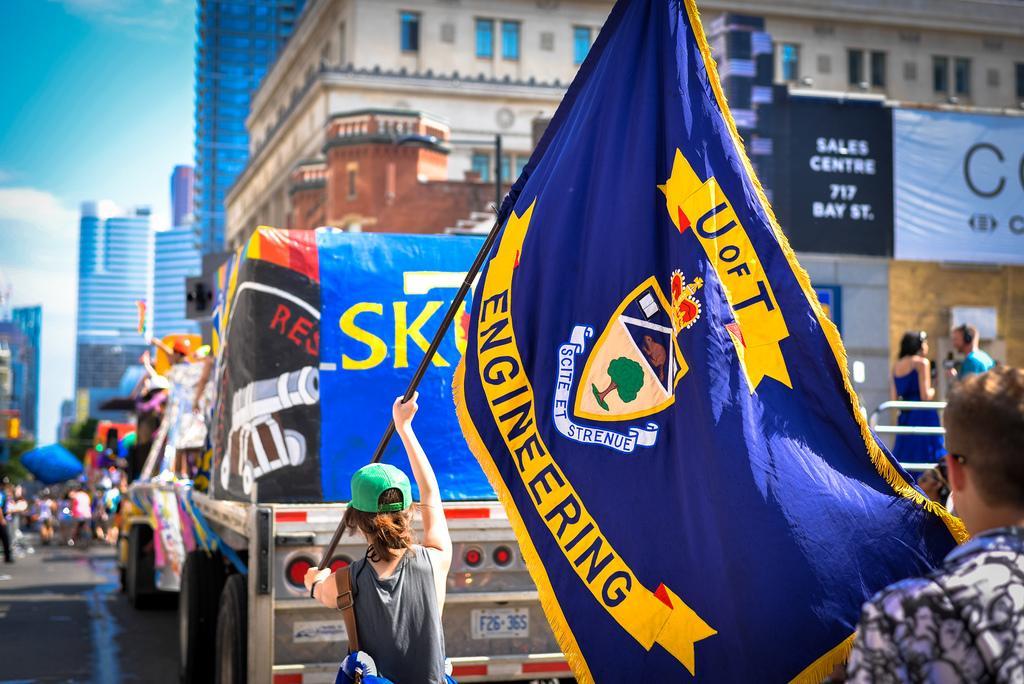Can you describe this image briefly? In this picture we can see some people, there are two vehicles in the front, in the background there are some buildings, on the left side we can see trees, a person in the front is holding a flag post, on the right side there is a hoarding, we can see the sky at the left top of the picture. 